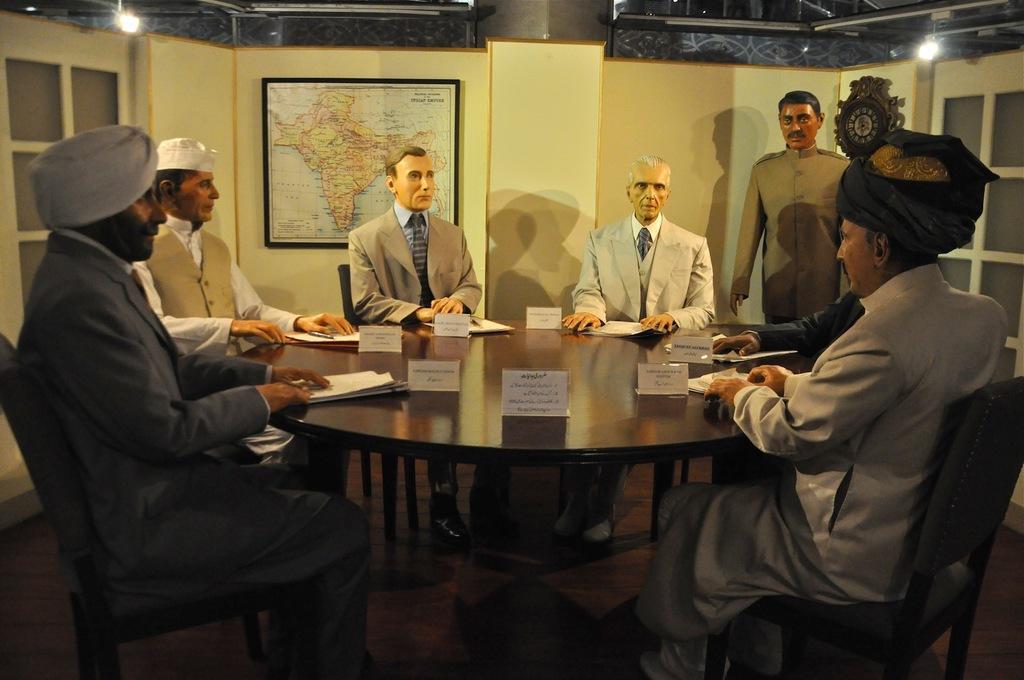Can you describe this image briefly? In this image we can see six people sitting in front of a table and one man is standing behind them, in the background we can see Indian map and also we can see a wall and a window in the background, on right top corner of the image we can see a light and also we can see some papers on the table. 